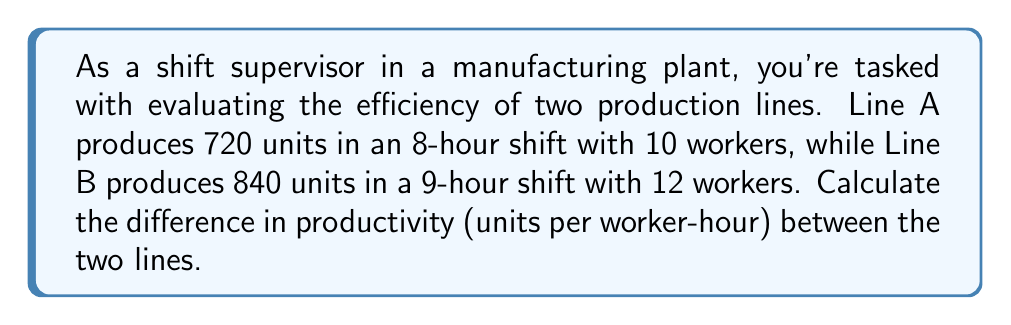Provide a solution to this math problem. Let's approach this step-by-step:

1. Calculate productivity for Line A:
   - Total units produced: 720
   - Total worker-hours: $10 \text{ workers} \times 8 \text{ hours} = 80 \text{ worker-hours}$
   - Productivity A = $\frac{\text{Units produced}}{\text{Worker-hours}} = \frac{720}{80} = 9 \text{ units/worker-hour}$

2. Calculate productivity for Line B:
   - Total units produced: 840
   - Total worker-hours: $12 \text{ workers} \times 9 \text{ hours} = 108 \text{ worker-hours}$
   - Productivity B = $\frac{\text{Units produced}}{\text{Worker-hours}} = \frac{840}{108} = 7.78 \text{ units/worker-hour}$

3. Calculate the difference in productivity:
   Difference = Productivity A - Productivity B
   $$ 9 - 7.78 = 1.22 \text{ units/worker-hour} $$

Therefore, Line A is more productive by 1.22 units per worker-hour.
Answer: 1.22 units/worker-hour 